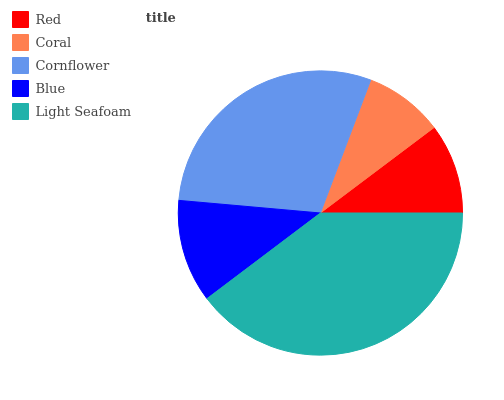Is Coral the minimum?
Answer yes or no. Yes. Is Light Seafoam the maximum?
Answer yes or no. Yes. Is Cornflower the minimum?
Answer yes or no. No. Is Cornflower the maximum?
Answer yes or no. No. Is Cornflower greater than Coral?
Answer yes or no. Yes. Is Coral less than Cornflower?
Answer yes or no. Yes. Is Coral greater than Cornflower?
Answer yes or no. No. Is Cornflower less than Coral?
Answer yes or no. No. Is Blue the high median?
Answer yes or no. Yes. Is Blue the low median?
Answer yes or no. Yes. Is Light Seafoam the high median?
Answer yes or no. No. Is Light Seafoam the low median?
Answer yes or no. No. 